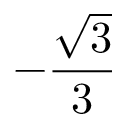Convert formula to latex. <formula><loc_0><loc_0><loc_500><loc_500>- { \frac { \sqrt { 3 } } { 3 } }</formula> 